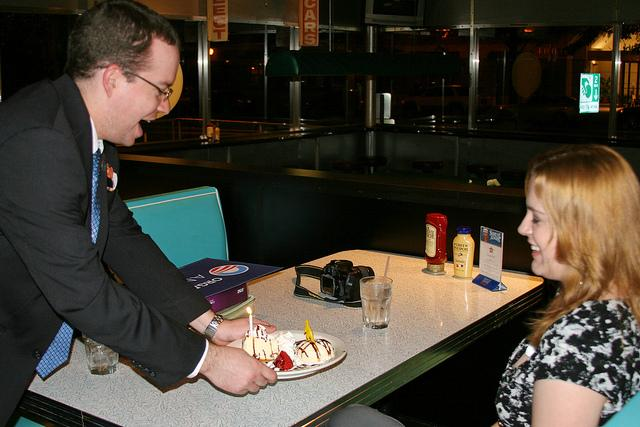Why is there a candle in the woman's dessert? Please explain your reasoning. to celebrate. It is most likely for her birthday. 